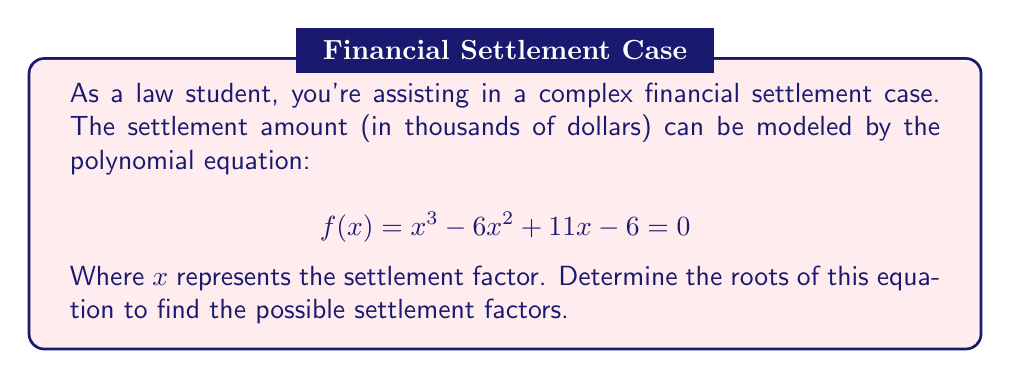Give your solution to this math problem. To solve this cubic equation, we'll use the rational root theorem and synthetic division.

1) Possible rational roots are factors of the constant term: $\pm 1, \pm 2, \pm 3, \pm 6$

2) Test these values using synthetic division:

For $x = 1$:
$$
\begin{array}{r|r r r r}
1 & 1 & -6 & 11 & -6 \\
& 1 & -5 & 6 \\
\hline
& 1 & -5 & 6 & 0
\end{array}
$$

We found one root: $x = 1$

3) Now divide the original polynomial by $(x-1)$:

$$(x^3 - 6x^2 + 11x - 6) \div (x-1) = x^2 - 5x + 6$$

4) Solve the quadratic equation $x^2 - 5x + 6 = 0$:

Using the quadratic formula: $x = \frac{-b \pm \sqrt{b^2 - 4ac}}{2a}$

$x = \frac{5 \pm \sqrt{25 - 24}}{2} = \frac{5 \pm 1}{2}$

5) This gives us the other two roots:

$x = \frac{5 + 1}{2} = 3$ and $x = \frac{5 - 1}{2} = 2$

Therefore, the roots of the equation are 1, 2, and 3.
Answer: The roots of the polynomial equation $f(x) = x^3 - 6x^2 + 11x - 6 = 0$ are $x = 1$, $x = 2$, and $x = 3$. These represent the possible settlement factors in the legal case. 